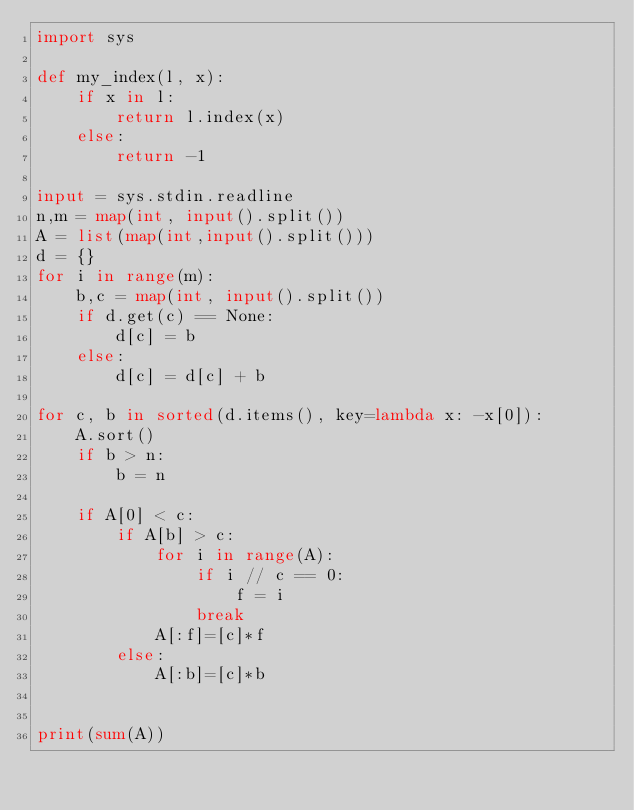Convert code to text. <code><loc_0><loc_0><loc_500><loc_500><_Python_>import sys

def my_index(l, x):
    if x in l:
        return l.index(x)
    else:
        return -1

input = sys.stdin.readline
n,m = map(int, input().split())
A = list(map(int,input().split()))
d = {}
for i in range(m):
    b,c = map(int, input().split())
    if d.get(c) == None:
        d[c] = b
    else:
        d[c] = d[c] + b

for c, b in sorted(d.items(), key=lambda x: -x[0]):
    A.sort()
    if b > n:
        b = n

    if A[0] < c:
        if A[b] > c:
            for i in range(A):
                if i // c == 0:
                    f = i
                break
            A[:f]=[c]*f
        else:
            A[:b]=[c]*b


print(sum(A))</code> 